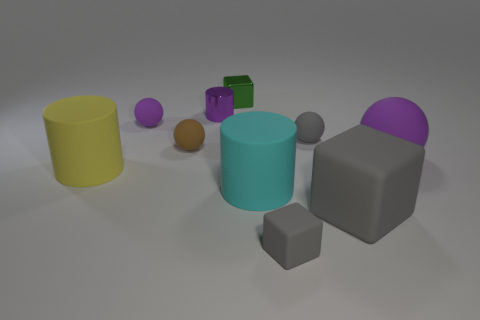Subtract all purple spheres. How many were subtracted if there are1purple spheres left? 1 Subtract all large rubber cylinders. How many cylinders are left? 1 Subtract all gray cubes. How many cubes are left? 1 Subtract 4 balls. How many balls are left? 0 Add 8 gray blocks. How many gray blocks exist? 10 Subtract 0 brown cylinders. How many objects are left? 10 Subtract all cubes. How many objects are left? 7 Subtract all blue spheres. Subtract all purple blocks. How many spheres are left? 4 Subtract all red spheres. How many red blocks are left? 0 Subtract all purple rubber objects. Subtract all small purple shiny cylinders. How many objects are left? 7 